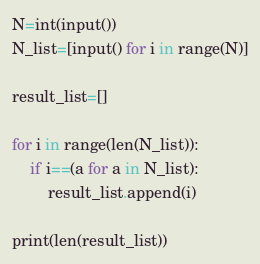<code> <loc_0><loc_0><loc_500><loc_500><_Python_>N=int(input())
N_list=[input() for i in range(N)]

result_list=[]

for i in range(len(N_list)):
    if i==(a for a in N_list):
        result_list.append(i)

print(len(result_list))</code> 